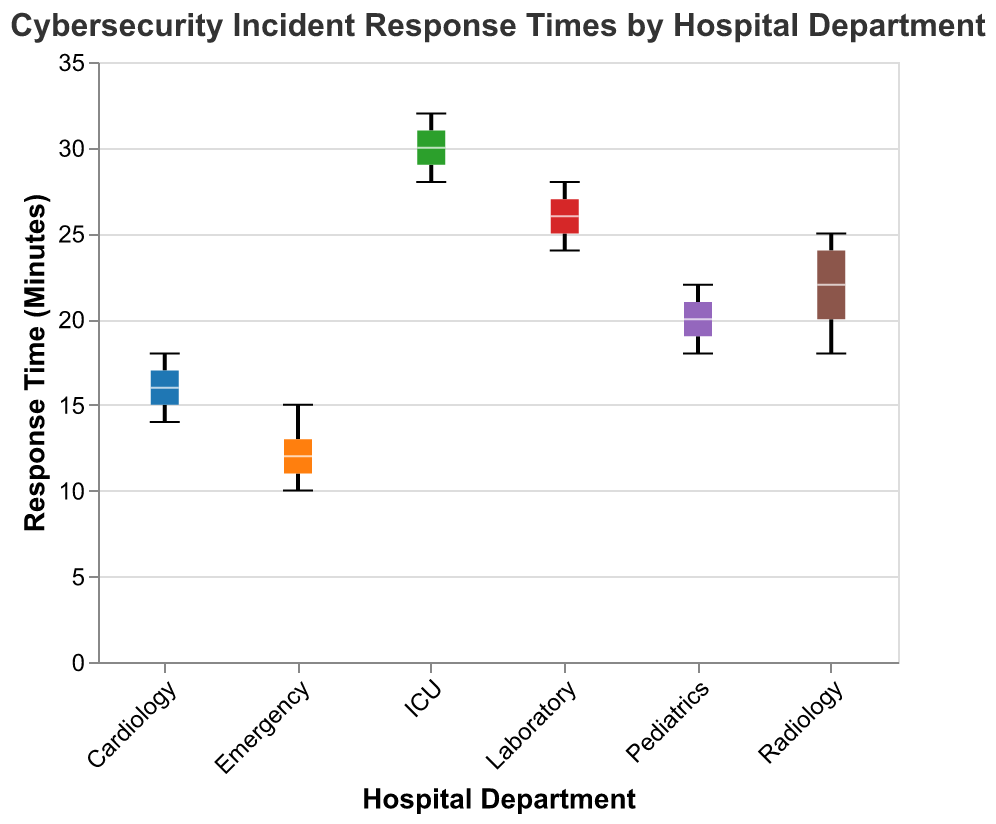What is the median response time for the Emergency department? The median for the Emergency department is found by organizing the data points in ascending order (10, 11, 12, 13, 15) and identifying the middle value, which is 12.
Answer: 12 Which department has the longest median response time? To determine this, we compare the medians of each department. The medians are: Emergency (12), Radiology (22), ICU (30), Pediatrics (20), Cardiology (16), and Laboratory (26). ICU has the longest median response time of 30 minutes.
Answer: ICU How does the median response time for Radiology compare to that of Pediatrics? The median response time for Radiology is 22 minutes, and for Pediatrics, it is 20 minutes. Comparing these, Radiology has a median response time that is 2 minutes longer than Pediatrics.
Answer: Radiology has a longer median response time by 2 minutes Which department shows the smallest range of response times? The range can be calculated by subtracting the minimum value from the maximum value for each department. The ranges are: Emergency (5, from 10 to 15), Radiology (7, from 18 to 25), ICU (4, from 28 to 32), Pediatrics (4, from 18 to 22), Cardiology (4, from 14 to 18), and Laboratory (4, from 24 to 28). Both ICU, Pediatrics, Cardiology, and Laboratory have the smallest range of 4 minutes.
Answer: ICU, Pediatrics, Cardiology, and Laboratory What are the outliers, if any, for the Emergency department? In a box plot, outliers are indicated by points that lie outside the whiskers of the plot. For the Emergency department, the plot does not depict any points outside the whiskers, indicating there are no outliers.
Answer: There are no outliers Which department has the second-highest median response time? We identify the medians: Emergency (12), Radiology (22), ICU (30), Pediatrics (20), Cardiology (16), and Laboratory (26). The second-highest median is for Laboratory with 26 minutes, as ICU has the highest median of 30.
Answer: Laboratory What is the interquartile range (IQR) for the Cardiology department? The IQR is calculated by subtracting the first quartile (Q1) from the third quartile (Q3). For Cardiology, with data points (14, 15, 16, 17, 18), Q1 is 15 and Q3 is 17. Thus, IQR = 17 - 15 = 2.
Answer: 2 What's the minimum response time recorded for the Radiology department? The minimum value in the data points for Radiology (18, 20, 22, 24, 25) is 18 minutes.
Answer: 18 How does the median response time of Emergency compare to the minimum response time of ICU? The median response time for Emergency is 12 minutes, and the minimum response time for ICU is 28 minutes. Therefore, ICU's minimum response time is significantly higher than Emergency's median.
Answer: ICU's minimum is 16 minutes higher than Emergency's median 